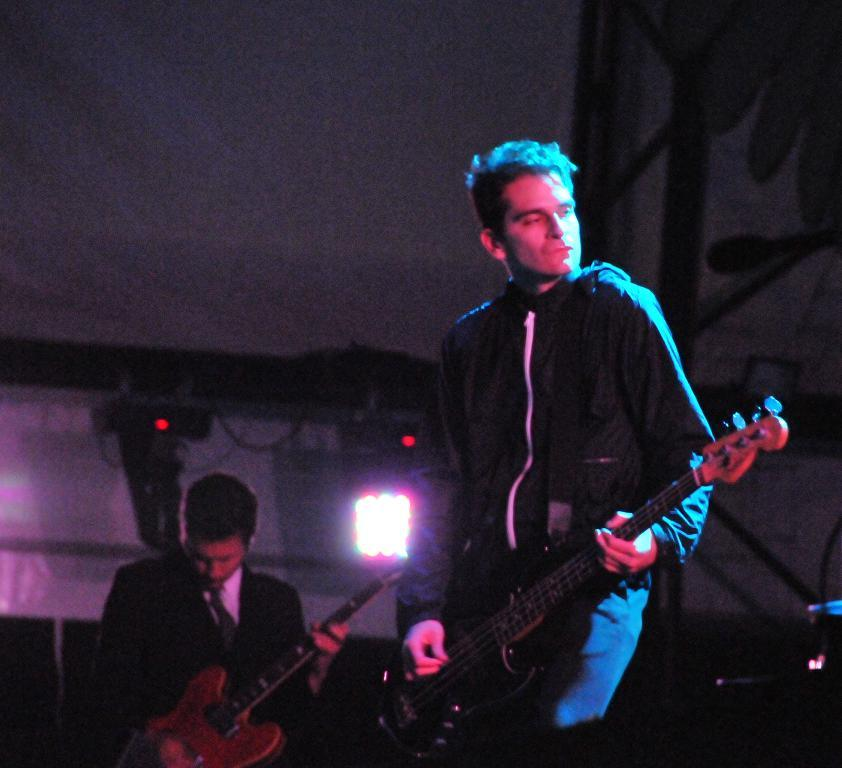How many people are in the image? There are two persons in the image. What are the persons doing in the image? The persons are playing guitars. What type of event might be taking place in the image? The scene appears to be a concert. What can be seen in the background of the image? There is a light visible in the background. What structure is present at the top of the image? There is a tent-like structure at the top of the image. How does the crowd react to the person's desire to play the guitar in the image? There is no crowd present in the image, and the desires of the persons are not mentioned. 